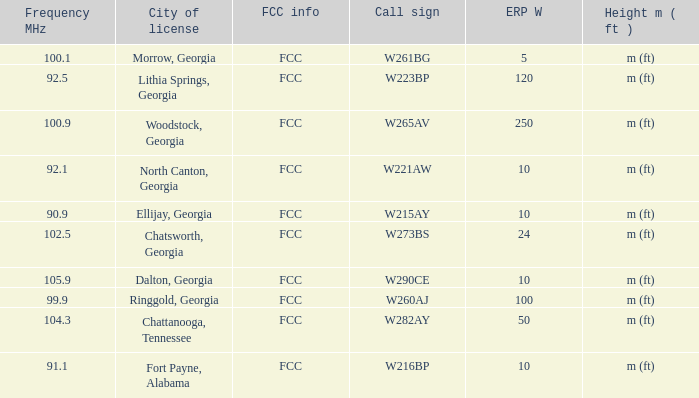What is the number of Frequency MHz in woodstock, georgia? 100.9. 